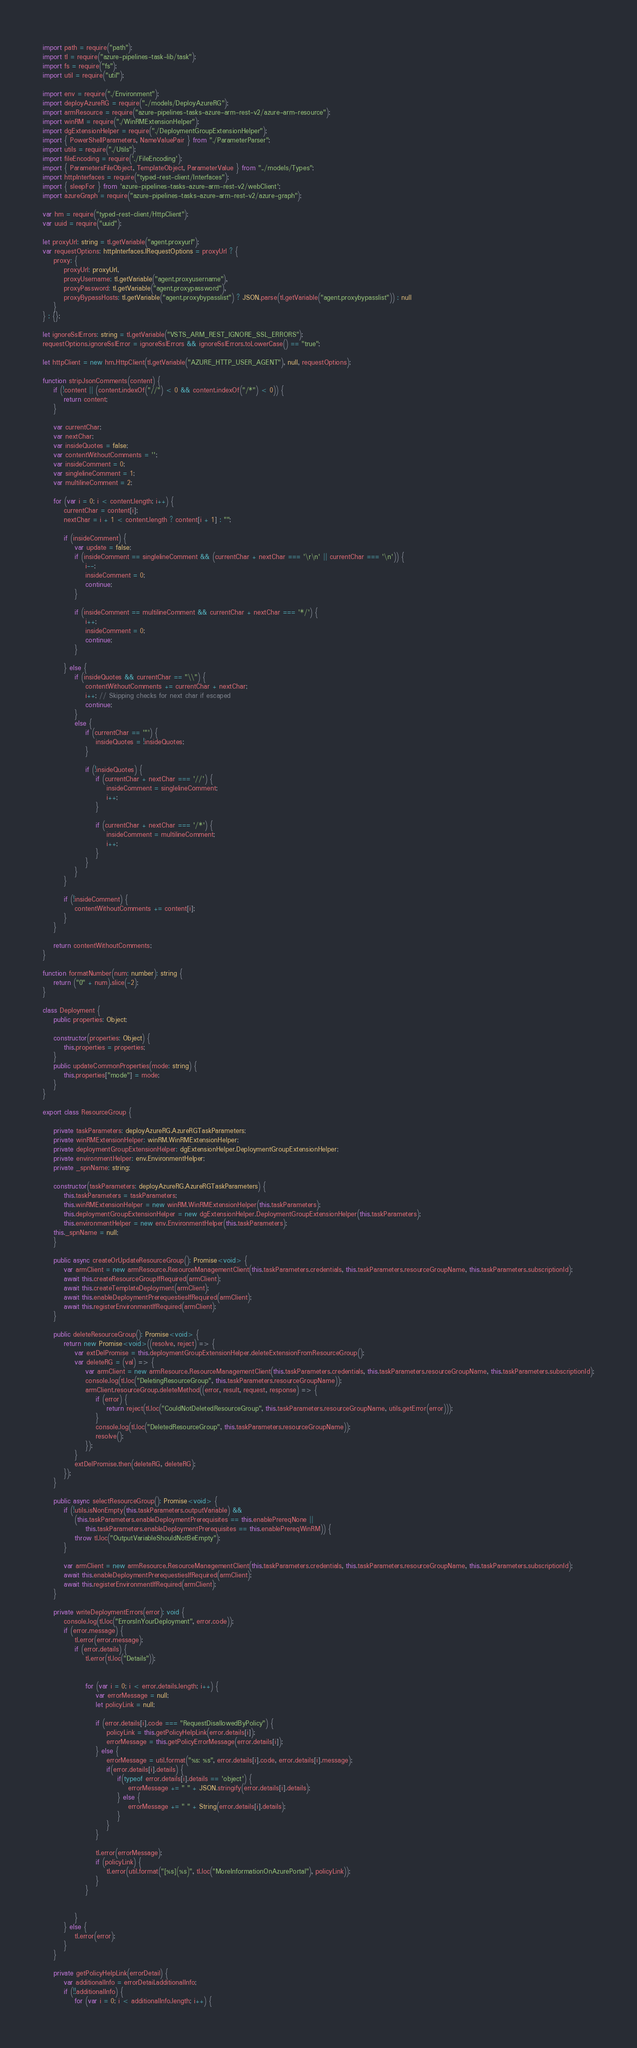<code> <loc_0><loc_0><loc_500><loc_500><_TypeScript_>import path = require("path");
import tl = require("azure-pipelines-task-lib/task");
import fs = require("fs");
import util = require("util");

import env = require("./Environment");
import deployAzureRG = require("../models/DeployAzureRG");
import armResource = require("azure-pipelines-tasks-azure-arm-rest-v2/azure-arm-resource");
import winRM = require("./WinRMExtensionHelper");
import dgExtensionHelper = require("./DeploymentGroupExtensionHelper");
import { PowerShellParameters, NameValuePair } from "./ParameterParser";
import utils = require("./Utils");
import fileEncoding = require('./FileEncoding');
import { ParametersFileObject, TemplateObject, ParameterValue } from "../models/Types";
import httpInterfaces = require("typed-rest-client/Interfaces");
import { sleepFor } from 'azure-pipelines-tasks-azure-arm-rest-v2/webClient';
import azureGraph = require("azure-pipelines-tasks-azure-arm-rest-v2/azure-graph");

var hm = require("typed-rest-client/HttpClient");
var uuid = require("uuid");

let proxyUrl: string = tl.getVariable("agent.proxyurl");
var requestOptions: httpInterfaces.IRequestOptions = proxyUrl ? {
    proxy: {
        proxyUrl: proxyUrl,
        proxyUsername: tl.getVariable("agent.proxyusername"),
        proxyPassword: tl.getVariable("agent.proxypassword"),
        proxyBypassHosts: tl.getVariable("agent.proxybypasslist") ? JSON.parse(tl.getVariable("agent.proxybypasslist")) : null
    }
} : {};

let ignoreSslErrors: string = tl.getVariable("VSTS_ARM_REST_IGNORE_SSL_ERRORS");
requestOptions.ignoreSslError = ignoreSslErrors && ignoreSslErrors.toLowerCase() == "true";

let httpClient = new hm.HttpClient(tl.getVariable("AZURE_HTTP_USER_AGENT"), null, requestOptions);

function stripJsonComments(content) {
    if (!content || (content.indexOf("//") < 0 && content.indexOf("/*") < 0)) {
        return content;
    }

    var currentChar;
    var nextChar;
    var insideQuotes = false;
    var contentWithoutComments = '';
    var insideComment = 0;
    var singlelineComment = 1;
    var multilineComment = 2;

    for (var i = 0; i < content.length; i++) {
        currentChar = content[i];
        nextChar = i + 1 < content.length ? content[i + 1] : "";

        if (insideComment) {
            var update = false;
            if (insideComment == singlelineComment && (currentChar + nextChar === '\r\n' || currentChar === '\n')) {
                i--;
                insideComment = 0;
                continue;
            }

            if (insideComment == multilineComment && currentChar + nextChar === '*/') {
                i++;
                insideComment = 0;
                continue;
            }

        } else {
            if (insideQuotes && currentChar == "\\") {
                contentWithoutComments += currentChar + nextChar;
                i++; // Skipping checks for next char if escaped
                continue;
            }
            else {
                if (currentChar == '"') {
                    insideQuotes = !insideQuotes;
                }

                if (!insideQuotes) {
                    if (currentChar + nextChar === '//') {
                        insideComment = singlelineComment;
                        i++;
                    }

                    if (currentChar + nextChar === '/*') {
                        insideComment = multilineComment;
                        i++;
                    }
                }
            }
        }

        if (!insideComment) {
            contentWithoutComments += content[i];
        }
    }

    return contentWithoutComments;
}

function formatNumber(num: number): string {
    return ("0" + num).slice(-2);
}

class Deployment {
    public properties: Object;

    constructor(properties: Object) {
        this.properties = properties;
    }
    public updateCommonProperties(mode: string) {
        this.properties["mode"] = mode;
    }
}

export class ResourceGroup {

    private taskParameters: deployAzureRG.AzureRGTaskParameters;
    private winRMExtensionHelper: winRM.WinRMExtensionHelper;
    private deploymentGroupExtensionHelper: dgExtensionHelper.DeploymentGroupExtensionHelper;
    private environmentHelper: env.EnvironmentHelper;
    private _spnName: string;

    constructor(taskParameters: deployAzureRG.AzureRGTaskParameters) {
        this.taskParameters = taskParameters;
        this.winRMExtensionHelper = new winRM.WinRMExtensionHelper(this.taskParameters);
        this.deploymentGroupExtensionHelper = new dgExtensionHelper.DeploymentGroupExtensionHelper(this.taskParameters);
        this.environmentHelper = new env.EnvironmentHelper(this.taskParameters);
	this._spnName = null;
    }

    public async createOrUpdateResourceGroup(): Promise<void> {
        var armClient = new armResource.ResourceManagementClient(this.taskParameters.credentials, this.taskParameters.resourceGroupName, this.taskParameters.subscriptionId);
        await this.createResourceGroupIfRequired(armClient);
        await this.createTemplateDeployment(armClient);
        await this.enableDeploymentPrerequestiesIfRequired(armClient);
        await this.registerEnvironmentIfRequired(armClient);
    }

    public deleteResourceGroup(): Promise<void> {
        return new Promise<void>((resolve, reject) => {
            var extDelPromise = this.deploymentGroupExtensionHelper.deleteExtensionFromResourceGroup();
            var deleteRG = (val) => {
                var armClient = new armResource.ResourceManagementClient(this.taskParameters.credentials, this.taskParameters.resourceGroupName, this.taskParameters.subscriptionId);
                console.log(tl.loc("DeletingResourceGroup", this.taskParameters.resourceGroupName));
                armClient.resourceGroup.deleteMethod((error, result, request, response) => {
                    if (error) {
                        return reject(tl.loc("CouldNotDeletedResourceGroup", this.taskParameters.resourceGroupName, utils.getError(error)));
                    }
                    console.log(tl.loc("DeletedResourceGroup", this.taskParameters.resourceGroupName));
                    resolve();
                });
            }
            extDelPromise.then(deleteRG, deleteRG);
        });
    }

    public async selectResourceGroup(): Promise<void> {
        if (!utils.isNonEmpty(this.taskParameters.outputVariable) &&
            (this.taskParameters.enableDeploymentPrerequisites == this.enablePrereqNone ||
                this.taskParameters.enableDeploymentPrerequisites == this.enablePrereqWinRM)) {
            throw tl.loc("OutputVariableShouldNotBeEmpty");
        }

        var armClient = new armResource.ResourceManagementClient(this.taskParameters.credentials, this.taskParameters.resourceGroupName, this.taskParameters.subscriptionId);
        await this.enableDeploymentPrerequestiesIfRequired(armClient);
        await this.registerEnvironmentIfRequired(armClient);
    }

    private writeDeploymentErrors(error): void {
        console.log(tl.loc("ErrorsInYourDeployment", error.code));
        if (error.message) {
            tl.error(error.message);
            if (error.details) {
                tl.error(tl.loc("Details"));


                for (var i = 0; i < error.details.length; i++) {
                    var errorMessage = null;
                    let policyLink = null;

                    if (error.details[i].code === "RequestDisallowedByPolicy") {
                        policyLink = this.getPolicyHelpLink(error.details[i]);
                        errorMessage = this.getPolicyErrorMessage(error.details[i]);
                    } else {
                        errorMessage = util.format("%s: %s", error.details[i].code, error.details[i].message);
                        if(error.details[i].details) {
                            if(typeof error.details[i].details == 'object') {
                                errorMessage += " " + JSON.stringify(error.details[i].details);
                            } else {
                                errorMessage += " " + String(error.details[i].details);
                            }
                        }
                    }

                    tl.error(errorMessage);
                    if (policyLink) {
                        tl.error(util.format("[%s](%s)", tl.loc("MoreInformationOnAzurePortal"), policyLink));
                    }
                }


            }
        } else {
            tl.error(error);
        }
    }

    private getPolicyHelpLink(errorDetail) {
        var additionalInfo = errorDetail.additionalInfo;
        if (!!additionalInfo) {
            for (var i = 0; i < additionalInfo.length; i++) {</code> 